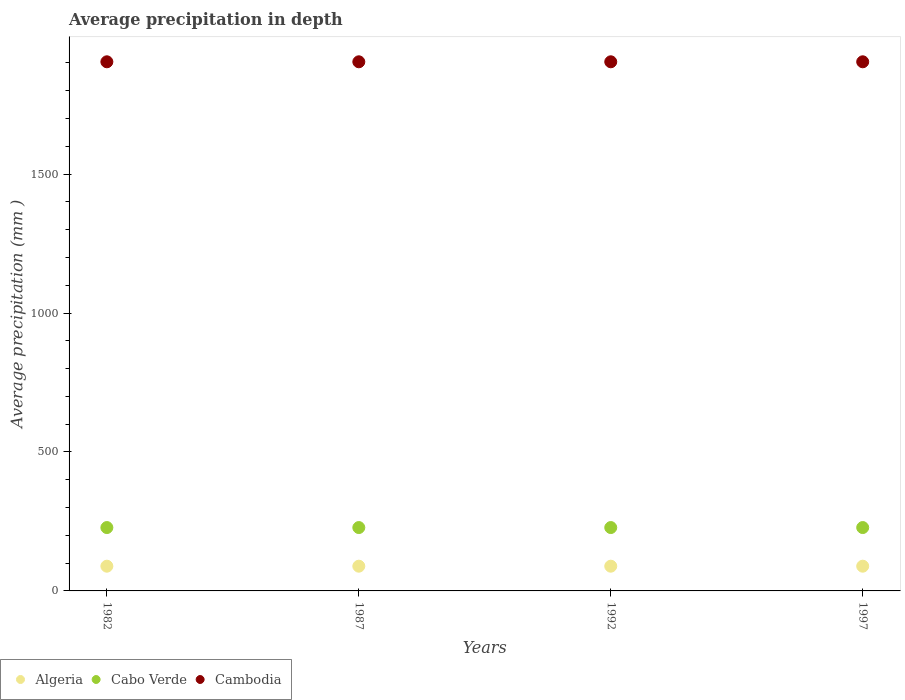What is the average precipitation in Cambodia in 1992?
Your answer should be very brief. 1904. Across all years, what is the maximum average precipitation in Algeria?
Your answer should be very brief. 89. Across all years, what is the minimum average precipitation in Cabo Verde?
Offer a very short reply. 228. In which year was the average precipitation in Cambodia minimum?
Offer a very short reply. 1982. What is the total average precipitation in Cabo Verde in the graph?
Your response must be concise. 912. What is the difference between the average precipitation in Cabo Verde in 1997 and the average precipitation in Cambodia in 1982?
Give a very brief answer. -1676. What is the average average precipitation in Algeria per year?
Give a very brief answer. 89. In the year 1997, what is the difference between the average precipitation in Cambodia and average precipitation in Cabo Verde?
Offer a terse response. 1676. In how many years, is the average precipitation in Cabo Verde greater than 1300 mm?
Offer a terse response. 0. What is the ratio of the average precipitation in Cambodia in 1992 to that in 1997?
Your answer should be very brief. 1. What is the difference between the highest and the lowest average precipitation in Cabo Verde?
Ensure brevity in your answer.  0. Is it the case that in every year, the sum of the average precipitation in Algeria and average precipitation in Cambodia  is greater than the average precipitation in Cabo Verde?
Make the answer very short. Yes. How many years are there in the graph?
Keep it short and to the point. 4. What is the difference between two consecutive major ticks on the Y-axis?
Make the answer very short. 500. Are the values on the major ticks of Y-axis written in scientific E-notation?
Your answer should be compact. No. Does the graph contain any zero values?
Make the answer very short. No. Where does the legend appear in the graph?
Offer a terse response. Bottom left. What is the title of the graph?
Your answer should be very brief. Average precipitation in depth. Does "European Union" appear as one of the legend labels in the graph?
Offer a terse response. No. What is the label or title of the X-axis?
Give a very brief answer. Years. What is the label or title of the Y-axis?
Offer a very short reply. Average precipitation (mm ). What is the Average precipitation (mm ) in Algeria in 1982?
Keep it short and to the point. 89. What is the Average precipitation (mm ) of Cabo Verde in 1982?
Offer a very short reply. 228. What is the Average precipitation (mm ) in Cambodia in 1982?
Your answer should be very brief. 1904. What is the Average precipitation (mm ) in Algeria in 1987?
Keep it short and to the point. 89. What is the Average precipitation (mm ) in Cabo Verde in 1987?
Give a very brief answer. 228. What is the Average precipitation (mm ) of Cambodia in 1987?
Offer a terse response. 1904. What is the Average precipitation (mm ) of Algeria in 1992?
Provide a short and direct response. 89. What is the Average precipitation (mm ) of Cabo Verde in 1992?
Keep it short and to the point. 228. What is the Average precipitation (mm ) of Cambodia in 1992?
Ensure brevity in your answer.  1904. What is the Average precipitation (mm ) in Algeria in 1997?
Keep it short and to the point. 89. What is the Average precipitation (mm ) in Cabo Verde in 1997?
Give a very brief answer. 228. What is the Average precipitation (mm ) of Cambodia in 1997?
Give a very brief answer. 1904. Across all years, what is the maximum Average precipitation (mm ) in Algeria?
Your answer should be very brief. 89. Across all years, what is the maximum Average precipitation (mm ) of Cabo Verde?
Your answer should be very brief. 228. Across all years, what is the maximum Average precipitation (mm ) of Cambodia?
Your answer should be compact. 1904. Across all years, what is the minimum Average precipitation (mm ) of Algeria?
Offer a terse response. 89. Across all years, what is the minimum Average precipitation (mm ) of Cabo Verde?
Your answer should be compact. 228. Across all years, what is the minimum Average precipitation (mm ) in Cambodia?
Provide a short and direct response. 1904. What is the total Average precipitation (mm ) in Algeria in the graph?
Provide a short and direct response. 356. What is the total Average precipitation (mm ) of Cabo Verde in the graph?
Ensure brevity in your answer.  912. What is the total Average precipitation (mm ) of Cambodia in the graph?
Give a very brief answer. 7616. What is the difference between the Average precipitation (mm ) of Algeria in 1982 and that in 1987?
Offer a terse response. 0. What is the difference between the Average precipitation (mm ) of Cabo Verde in 1982 and that in 1987?
Provide a succinct answer. 0. What is the difference between the Average precipitation (mm ) in Cambodia in 1982 and that in 1992?
Provide a succinct answer. 0. What is the difference between the Average precipitation (mm ) in Algeria in 1982 and that in 1997?
Provide a short and direct response. 0. What is the difference between the Average precipitation (mm ) of Cabo Verde in 1982 and that in 1997?
Your answer should be very brief. 0. What is the difference between the Average precipitation (mm ) in Cabo Verde in 1987 and that in 1992?
Your response must be concise. 0. What is the difference between the Average precipitation (mm ) of Cambodia in 1987 and that in 1992?
Your answer should be very brief. 0. What is the difference between the Average precipitation (mm ) in Algeria in 1987 and that in 1997?
Give a very brief answer. 0. What is the difference between the Average precipitation (mm ) of Cabo Verde in 1992 and that in 1997?
Your response must be concise. 0. What is the difference between the Average precipitation (mm ) in Algeria in 1982 and the Average precipitation (mm ) in Cabo Verde in 1987?
Your response must be concise. -139. What is the difference between the Average precipitation (mm ) in Algeria in 1982 and the Average precipitation (mm ) in Cambodia in 1987?
Your response must be concise. -1815. What is the difference between the Average precipitation (mm ) in Cabo Verde in 1982 and the Average precipitation (mm ) in Cambodia in 1987?
Your answer should be very brief. -1676. What is the difference between the Average precipitation (mm ) of Algeria in 1982 and the Average precipitation (mm ) of Cabo Verde in 1992?
Your response must be concise. -139. What is the difference between the Average precipitation (mm ) of Algeria in 1982 and the Average precipitation (mm ) of Cambodia in 1992?
Provide a short and direct response. -1815. What is the difference between the Average precipitation (mm ) of Cabo Verde in 1982 and the Average precipitation (mm ) of Cambodia in 1992?
Make the answer very short. -1676. What is the difference between the Average precipitation (mm ) in Algeria in 1982 and the Average precipitation (mm ) in Cabo Verde in 1997?
Your answer should be compact. -139. What is the difference between the Average precipitation (mm ) of Algeria in 1982 and the Average precipitation (mm ) of Cambodia in 1997?
Give a very brief answer. -1815. What is the difference between the Average precipitation (mm ) of Cabo Verde in 1982 and the Average precipitation (mm ) of Cambodia in 1997?
Offer a very short reply. -1676. What is the difference between the Average precipitation (mm ) in Algeria in 1987 and the Average precipitation (mm ) in Cabo Verde in 1992?
Make the answer very short. -139. What is the difference between the Average precipitation (mm ) of Algeria in 1987 and the Average precipitation (mm ) of Cambodia in 1992?
Give a very brief answer. -1815. What is the difference between the Average precipitation (mm ) of Cabo Verde in 1987 and the Average precipitation (mm ) of Cambodia in 1992?
Ensure brevity in your answer.  -1676. What is the difference between the Average precipitation (mm ) in Algeria in 1987 and the Average precipitation (mm ) in Cabo Verde in 1997?
Your answer should be very brief. -139. What is the difference between the Average precipitation (mm ) in Algeria in 1987 and the Average precipitation (mm ) in Cambodia in 1997?
Offer a very short reply. -1815. What is the difference between the Average precipitation (mm ) in Cabo Verde in 1987 and the Average precipitation (mm ) in Cambodia in 1997?
Your response must be concise. -1676. What is the difference between the Average precipitation (mm ) of Algeria in 1992 and the Average precipitation (mm ) of Cabo Verde in 1997?
Offer a terse response. -139. What is the difference between the Average precipitation (mm ) of Algeria in 1992 and the Average precipitation (mm ) of Cambodia in 1997?
Offer a terse response. -1815. What is the difference between the Average precipitation (mm ) in Cabo Verde in 1992 and the Average precipitation (mm ) in Cambodia in 1997?
Offer a terse response. -1676. What is the average Average precipitation (mm ) of Algeria per year?
Provide a short and direct response. 89. What is the average Average precipitation (mm ) of Cabo Verde per year?
Keep it short and to the point. 228. What is the average Average precipitation (mm ) in Cambodia per year?
Keep it short and to the point. 1904. In the year 1982, what is the difference between the Average precipitation (mm ) in Algeria and Average precipitation (mm ) in Cabo Verde?
Your answer should be very brief. -139. In the year 1982, what is the difference between the Average precipitation (mm ) of Algeria and Average precipitation (mm ) of Cambodia?
Ensure brevity in your answer.  -1815. In the year 1982, what is the difference between the Average precipitation (mm ) of Cabo Verde and Average precipitation (mm ) of Cambodia?
Keep it short and to the point. -1676. In the year 1987, what is the difference between the Average precipitation (mm ) in Algeria and Average precipitation (mm ) in Cabo Verde?
Your answer should be compact. -139. In the year 1987, what is the difference between the Average precipitation (mm ) in Algeria and Average precipitation (mm ) in Cambodia?
Make the answer very short. -1815. In the year 1987, what is the difference between the Average precipitation (mm ) in Cabo Verde and Average precipitation (mm ) in Cambodia?
Your answer should be compact. -1676. In the year 1992, what is the difference between the Average precipitation (mm ) of Algeria and Average precipitation (mm ) of Cabo Verde?
Provide a short and direct response. -139. In the year 1992, what is the difference between the Average precipitation (mm ) of Algeria and Average precipitation (mm ) of Cambodia?
Ensure brevity in your answer.  -1815. In the year 1992, what is the difference between the Average precipitation (mm ) of Cabo Verde and Average precipitation (mm ) of Cambodia?
Offer a terse response. -1676. In the year 1997, what is the difference between the Average precipitation (mm ) in Algeria and Average precipitation (mm ) in Cabo Verde?
Provide a succinct answer. -139. In the year 1997, what is the difference between the Average precipitation (mm ) of Algeria and Average precipitation (mm ) of Cambodia?
Make the answer very short. -1815. In the year 1997, what is the difference between the Average precipitation (mm ) in Cabo Verde and Average precipitation (mm ) in Cambodia?
Your response must be concise. -1676. What is the ratio of the Average precipitation (mm ) of Algeria in 1982 to that in 1987?
Make the answer very short. 1. What is the ratio of the Average precipitation (mm ) in Cabo Verde in 1982 to that in 1987?
Keep it short and to the point. 1. What is the ratio of the Average precipitation (mm ) of Cambodia in 1982 to that in 1987?
Your answer should be very brief. 1. What is the ratio of the Average precipitation (mm ) in Algeria in 1982 to that in 1992?
Keep it short and to the point. 1. What is the ratio of the Average precipitation (mm ) in Cabo Verde in 1982 to that in 1997?
Give a very brief answer. 1. What is the ratio of the Average precipitation (mm ) in Cabo Verde in 1987 to that in 1992?
Provide a short and direct response. 1. What is the ratio of the Average precipitation (mm ) of Cambodia in 1987 to that in 1997?
Provide a succinct answer. 1. What is the ratio of the Average precipitation (mm ) of Algeria in 1992 to that in 1997?
Your response must be concise. 1. What is the ratio of the Average precipitation (mm ) in Cabo Verde in 1992 to that in 1997?
Provide a short and direct response. 1. What is the difference between the highest and the second highest Average precipitation (mm ) in Algeria?
Offer a terse response. 0. What is the difference between the highest and the second highest Average precipitation (mm ) in Cabo Verde?
Ensure brevity in your answer.  0. What is the difference between the highest and the lowest Average precipitation (mm ) of Cabo Verde?
Provide a short and direct response. 0. 